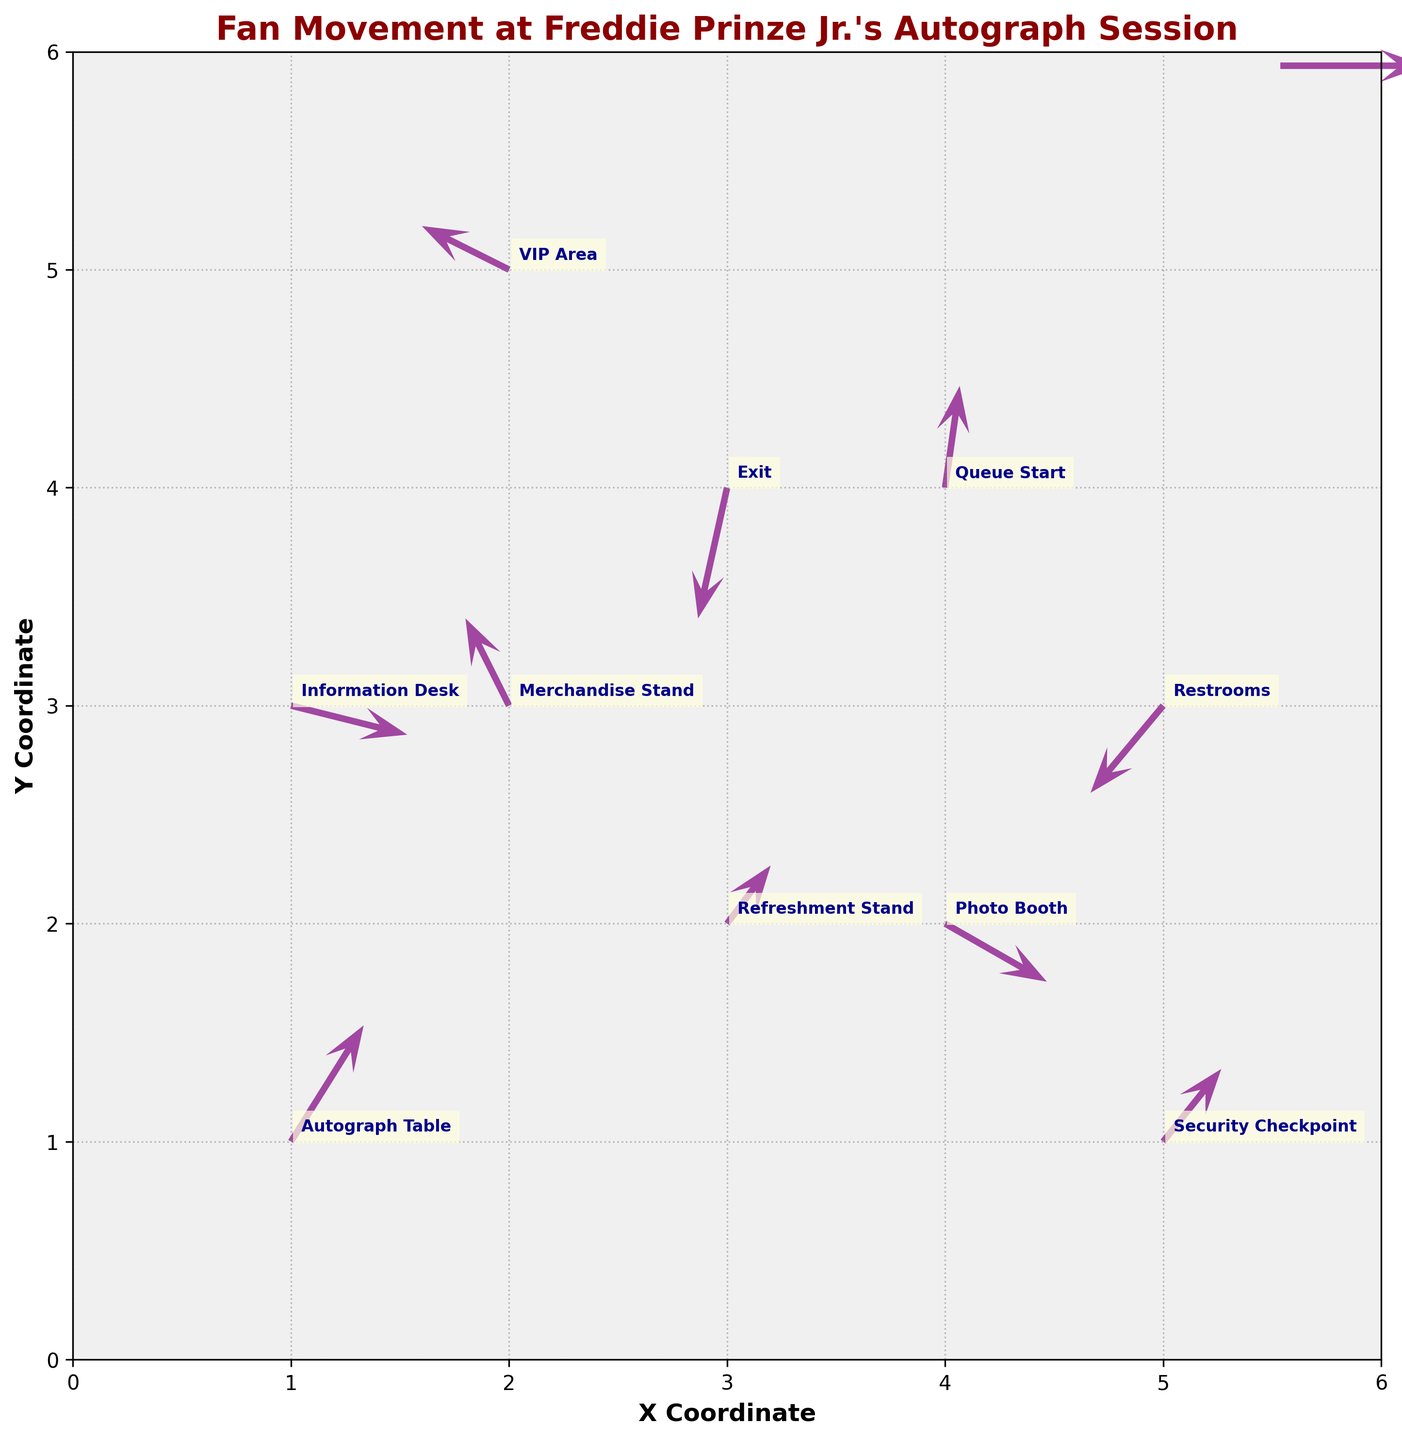What is the title of the figure? The title of the figure is located at the top and is often the easiest element to spot. In this case, it is in bold and a dark red color.
Answer: Fan Movement at Freddie Prinze Jr.'s Autograph Session How many locations are labeled in the plot? Count the number of individual location labels annotated in the plot. Each label corresponds to a fan movement starting point.
Answer: 10 Which direction are fans moving from the Information Desk? Observe the arrow originating from the Information Desk and note its direction. This arrow shows the u and v components of the vector.
Answer: South-East Which location has the strongest westward movement of fans? Compare the u components of all arrows to identify which one is the most negative, indicating westward movement. An arrow originating from the Merchandise Stand points the most westward.
Answer: Merchandise Stand Do fans tend to move towards or away from the Exit area? Look at the direction of the arrow at the Exit to check if it points towards (positive angle to X and Y) or away (negative angle to X and Y) from the Exit.
Answer: Away What is the general trend of fan movements around the Autograph Table? Check the magnitude and direction of the arrow originating from the Autograph Table. This shows the overall movement fans are taking from this location.
Answer: North-East Which location shows a nearly vertical upward movement of fans? Find the arrow that points almost straight up by looking at its v component and minimal horizontal u component.
Answer: Queue Start Compare the directions of fans moving from the VIP Area and the Photo Booth. Which direction do fans from the VIP Area move relative to those from the Photo Booth? Observe the arrows from both locations: VIP Area moves West-North, and Photo Booth moves East-South. Then, contrast the two directions.
Answer: VIP Area: West-North, Photo Booth: East-South Are there any locations where fans move South-West? Detect if any arrows point towards the South-West direction by checking if both u and v components are negative. The arrow from the Restrooms fits this criterion.
Answer: Yes Which location has the smallest arrow, indicating the least movement or small changes in fan positions? Evaluate the length of arrows to find the smallest one. The arrow from the Refreshment Stand is shorter compared to others.
Answer: Refreshment Stand 